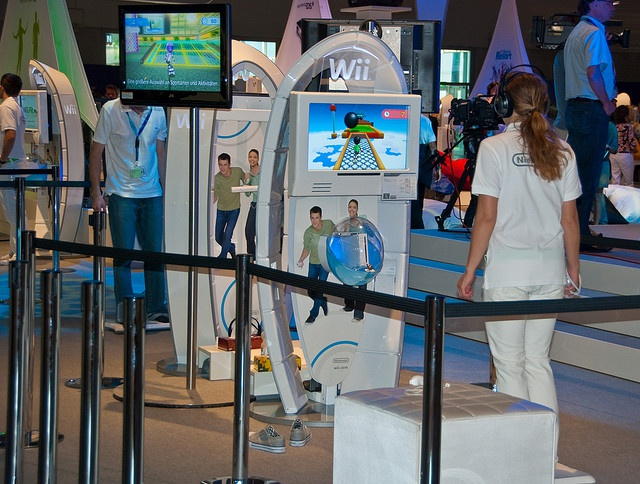Describe the objects in this image and their specific colors. I can see people in black, darkgray, brown, and gray tones, tv in black, darkgray, lightblue, and gray tones, people in black, darkblue, and gray tones, tv in black, teal, and green tones, and people in black, gray, navy, and blue tones in this image. 